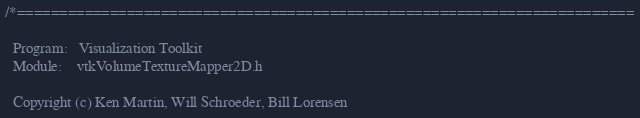Convert code to text. <code><loc_0><loc_0><loc_500><loc_500><_C_>/*=========================================================================

  Program:   Visualization Toolkit
  Module:    vtkVolumeTextureMapper2D.h

  Copyright (c) Ken Martin, Will Schroeder, Bill Lorensen</code> 